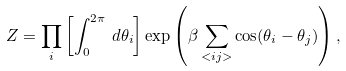<formula> <loc_0><loc_0><loc_500><loc_500>Z = \prod _ { i } \left [ \int _ { 0 } ^ { 2 \pi } \, d \theta _ { i } \right ] \exp \left ( \beta \sum _ { < i j > } \cos ( \theta _ { i } - \theta _ { j } ) \right ) ,</formula> 